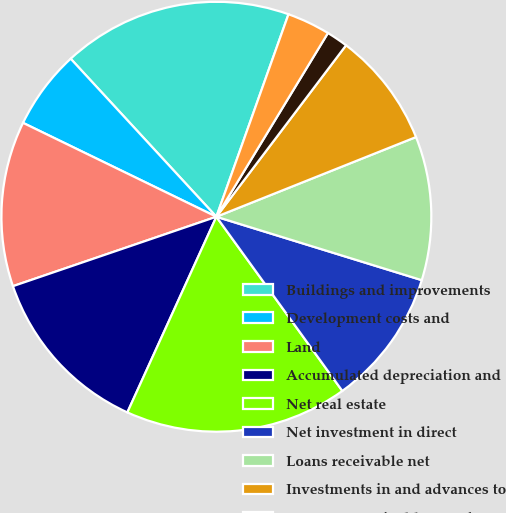<chart> <loc_0><loc_0><loc_500><loc_500><pie_chart><fcel>Buildings and improvements<fcel>Development costs and<fcel>Land<fcel>Accumulated depreciation and<fcel>Net real estate<fcel>Net investment in direct<fcel>Loans receivable net<fcel>Investments in and advances to<fcel>Accounts receivable net of<fcel>Cash and cash equivalents<nl><fcel>17.3%<fcel>5.95%<fcel>12.43%<fcel>12.97%<fcel>16.76%<fcel>10.27%<fcel>10.81%<fcel>8.65%<fcel>1.62%<fcel>3.24%<nl></chart> 